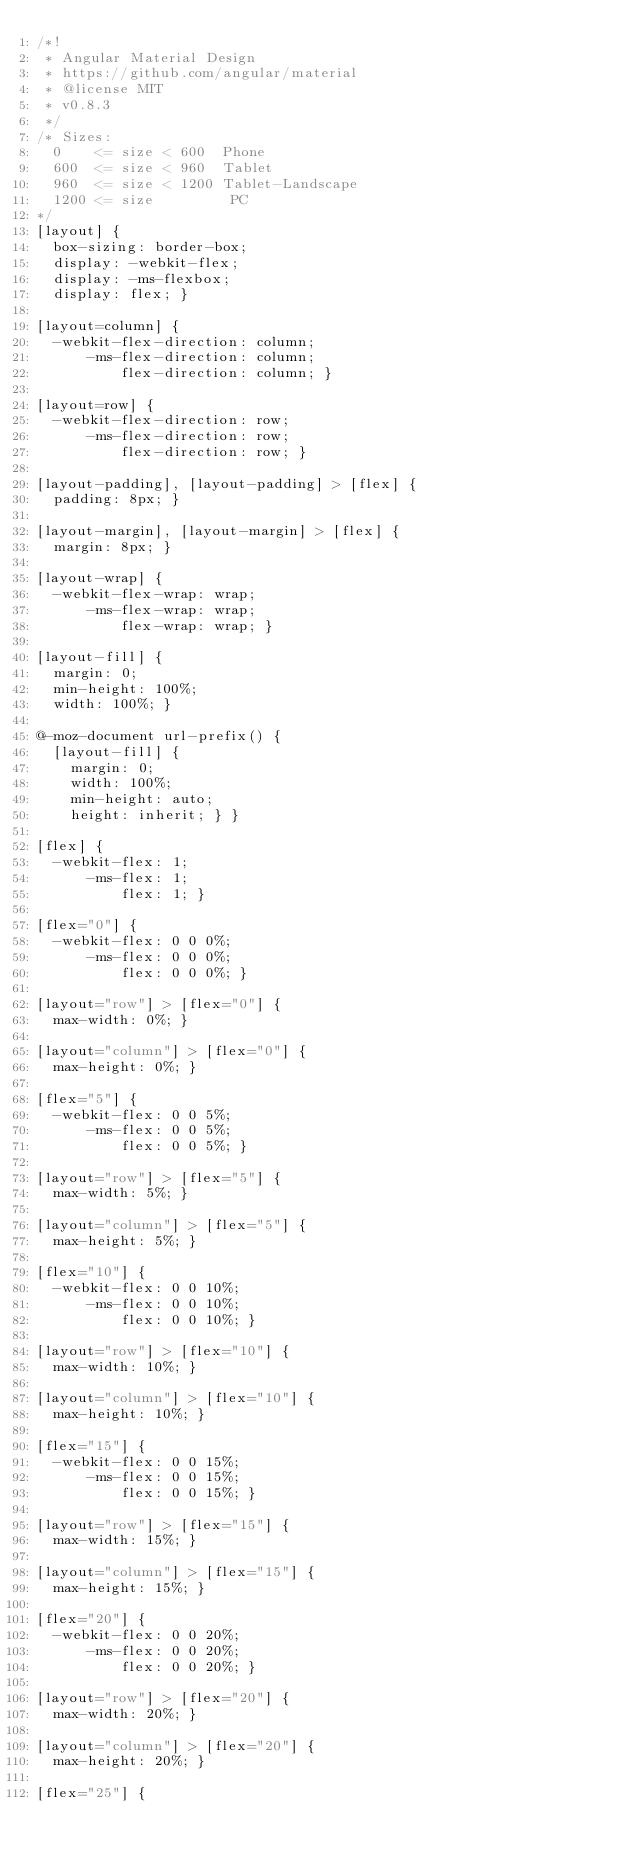<code> <loc_0><loc_0><loc_500><loc_500><_CSS_>/*!
 * Angular Material Design
 * https://github.com/angular/material
 * @license MIT
 * v0.8.3
 */
/* Sizes:
  0    <= size < 600  Phone
  600  <= size < 960  Tablet
  960  <= size < 1200 Tablet-Landscape
  1200 <= size         PC
*/
[layout] {
  box-sizing: border-box;
  display: -webkit-flex;
  display: -ms-flexbox;
  display: flex; }

[layout=column] {
  -webkit-flex-direction: column;
      -ms-flex-direction: column;
          flex-direction: column; }

[layout=row] {
  -webkit-flex-direction: row;
      -ms-flex-direction: row;
          flex-direction: row; }

[layout-padding], [layout-padding] > [flex] {
  padding: 8px; }

[layout-margin], [layout-margin] > [flex] {
  margin: 8px; }

[layout-wrap] {
  -webkit-flex-wrap: wrap;
      -ms-flex-wrap: wrap;
          flex-wrap: wrap; }

[layout-fill] {
  margin: 0;
  min-height: 100%;
  width: 100%; }

@-moz-document url-prefix() {
  [layout-fill] {
    margin: 0;
    width: 100%;
    min-height: auto;
    height: inherit; } }

[flex] {
  -webkit-flex: 1;
      -ms-flex: 1;
          flex: 1; }

[flex="0"] {
  -webkit-flex: 0 0 0%;
      -ms-flex: 0 0 0%;
          flex: 0 0 0%; }

[layout="row"] > [flex="0"] {
  max-width: 0%; }

[layout="column"] > [flex="0"] {
  max-height: 0%; }

[flex="5"] {
  -webkit-flex: 0 0 5%;
      -ms-flex: 0 0 5%;
          flex: 0 0 5%; }

[layout="row"] > [flex="5"] {
  max-width: 5%; }

[layout="column"] > [flex="5"] {
  max-height: 5%; }

[flex="10"] {
  -webkit-flex: 0 0 10%;
      -ms-flex: 0 0 10%;
          flex: 0 0 10%; }

[layout="row"] > [flex="10"] {
  max-width: 10%; }

[layout="column"] > [flex="10"] {
  max-height: 10%; }

[flex="15"] {
  -webkit-flex: 0 0 15%;
      -ms-flex: 0 0 15%;
          flex: 0 0 15%; }

[layout="row"] > [flex="15"] {
  max-width: 15%; }

[layout="column"] > [flex="15"] {
  max-height: 15%; }

[flex="20"] {
  -webkit-flex: 0 0 20%;
      -ms-flex: 0 0 20%;
          flex: 0 0 20%; }

[layout="row"] > [flex="20"] {
  max-width: 20%; }

[layout="column"] > [flex="20"] {
  max-height: 20%; }

[flex="25"] {</code> 